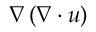Convert formula to latex. <formula><loc_0><loc_0><loc_500><loc_500>\nabla \left ( \nabla \cdot u \right )</formula> 